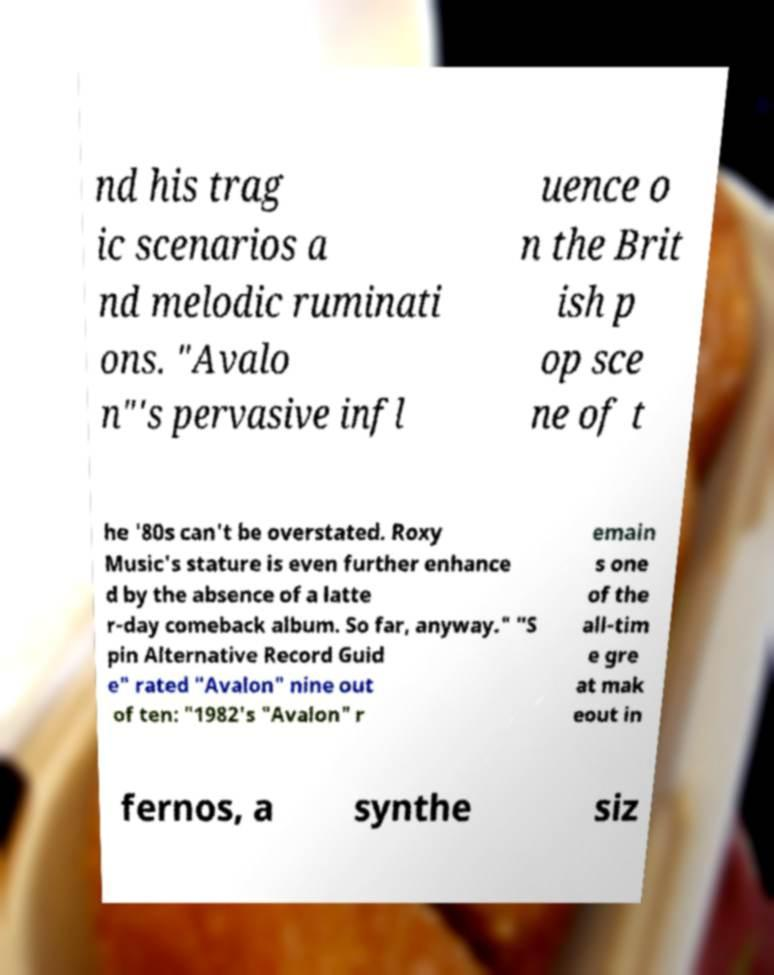For documentation purposes, I need the text within this image transcribed. Could you provide that? nd his trag ic scenarios a nd melodic ruminati ons. "Avalo n"'s pervasive infl uence o n the Brit ish p op sce ne of t he '80s can't be overstated. Roxy Music's stature is even further enhance d by the absence of a latte r-day comeback album. So far, anyway." "S pin Alternative Record Guid e" rated "Avalon" nine out of ten: "1982's "Avalon" r emain s one of the all-tim e gre at mak eout in fernos, a synthe siz 